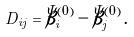<formula> <loc_0><loc_0><loc_500><loc_500>D _ { i j } = \bar { \beta } _ { i } ^ { ( 0 ) } - \bar { \beta } _ { j } ^ { ( 0 ) } \, .</formula> 